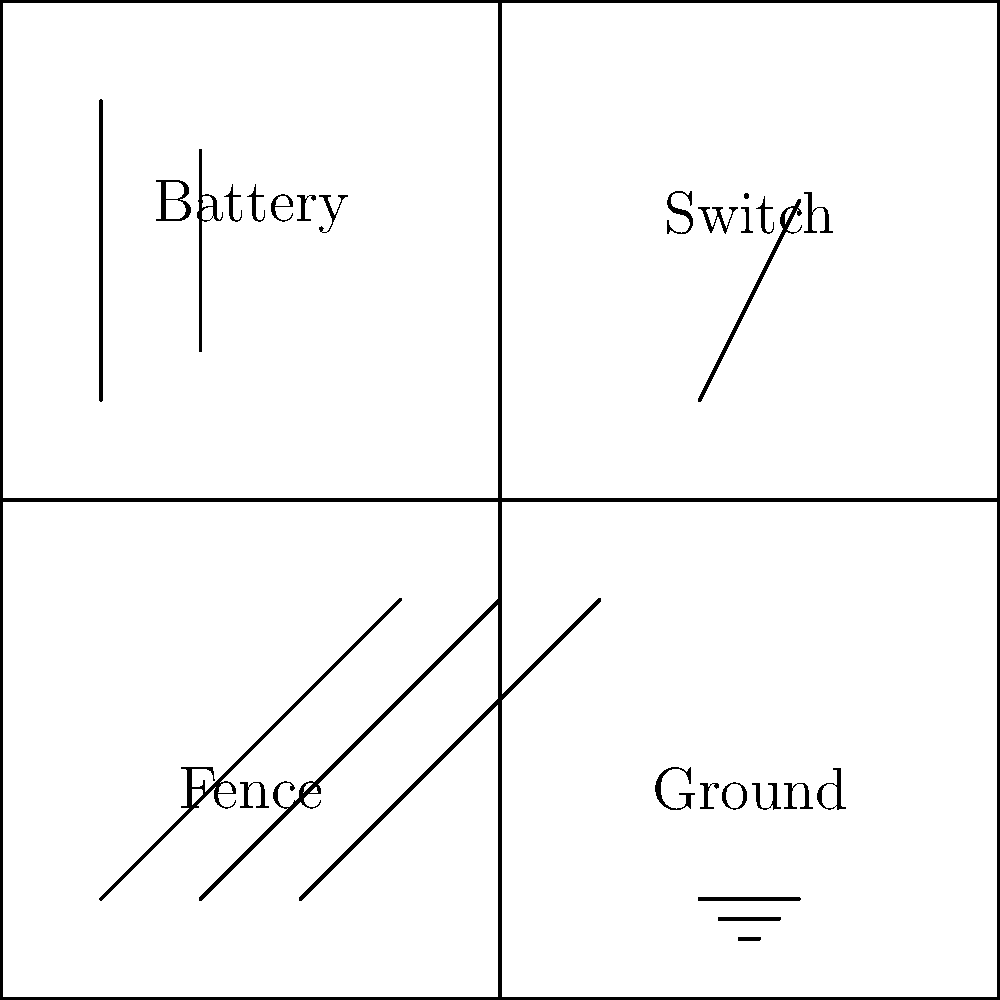You're installing an electric fence system for a client's vegetable garden to deter pests. The fence isn't working, and you suspect an issue with the circuit. Using the simplified circuit diagram, identify the most likely cause of the malfunction if the battery is new and properly connected. To troubleshoot the electric fence circuit, let's follow these steps:

1. Verify the battery: The question states that the battery is new and properly connected, so we can rule this out as the cause of the problem.

2. Check the switch: In the diagram, we can see that the switch is open (not connecting the circuit). This is the most likely cause of the malfunction.

3. Examine the fence: The fence appears to be properly connected in the circuit diagram.

4. Check the ground: The ground connection seems to be correctly illustrated in the diagram.

5. Consider other factors: Since all other components appear to be in order, the open switch is the most probable cause of the fence not working.

In an electric fence circuit, the switch needs to be closed to complete the circuit and allow current to flow through the fence. When the switch is open, it creates a break in the circuit, preventing the fence from becoming electrified.
Answer: Open switch 